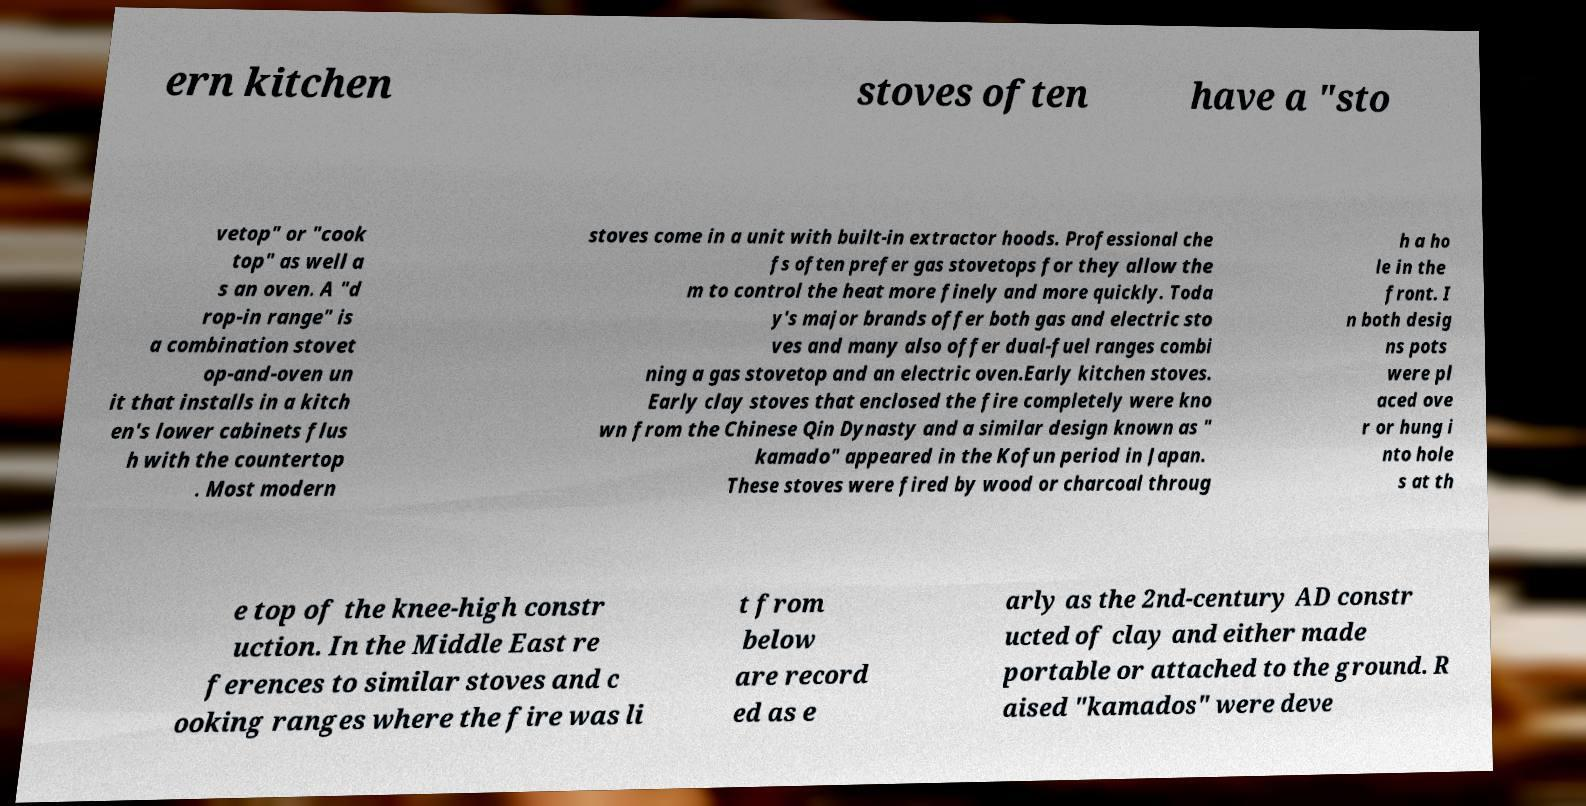I need the written content from this picture converted into text. Can you do that? ern kitchen stoves often have a "sto vetop" or "cook top" as well a s an oven. A "d rop-in range" is a combination stovet op-and-oven un it that installs in a kitch en's lower cabinets flus h with the countertop . Most modern stoves come in a unit with built-in extractor hoods. Professional che fs often prefer gas stovetops for they allow the m to control the heat more finely and more quickly. Toda y's major brands offer both gas and electric sto ves and many also offer dual-fuel ranges combi ning a gas stovetop and an electric oven.Early kitchen stoves. Early clay stoves that enclosed the fire completely were kno wn from the Chinese Qin Dynasty and a similar design known as " kamado" appeared in the Kofun period in Japan. These stoves were fired by wood or charcoal throug h a ho le in the front. I n both desig ns pots were pl aced ove r or hung i nto hole s at th e top of the knee-high constr uction. In the Middle East re ferences to similar stoves and c ooking ranges where the fire was li t from below are record ed as e arly as the 2nd-century AD constr ucted of clay and either made portable or attached to the ground. R aised "kamados" were deve 